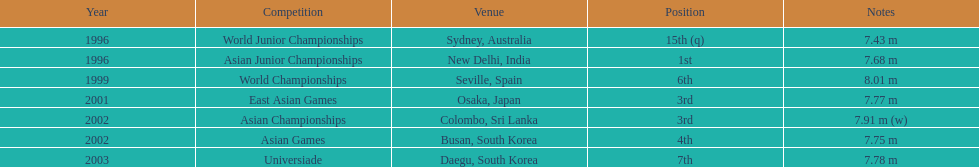How many competitions did he place in the top three? 3. 